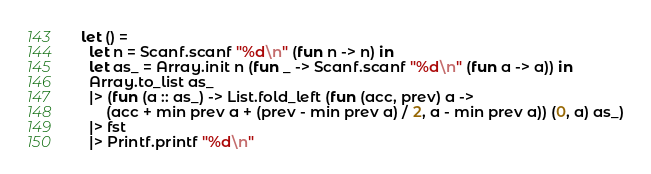Convert code to text. <code><loc_0><loc_0><loc_500><loc_500><_OCaml_>let () =
  let n = Scanf.scanf "%d\n" (fun n -> n) in
  let as_ = Array.init n (fun _ -> Scanf.scanf "%d\n" (fun a -> a)) in
  Array.to_list as_
  |> (fun (a :: as_) -> List.fold_left (fun (acc, prev) a ->
      (acc + min prev a + (prev - min prev a) / 2, a - min prev a)) (0, a) as_)
  |> fst
  |> Printf.printf "%d\n"</code> 